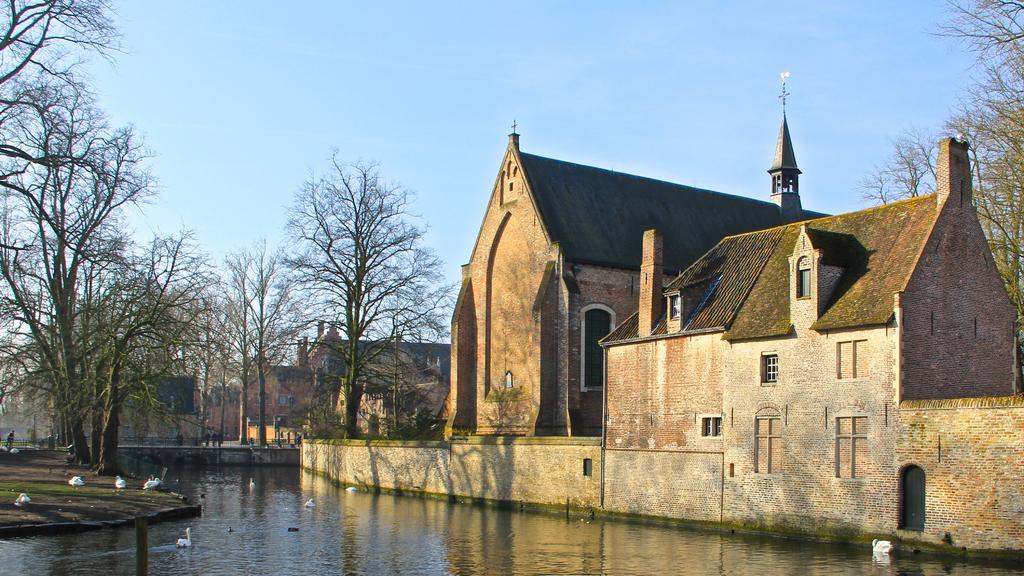How would you summarize this image in a sentence or two? In this image I can see the water, the ground, few birds which are white in color on the surface of the water and on the ground, few people standing on the ground, few trees and few buildings. In the background I can see the sky. 